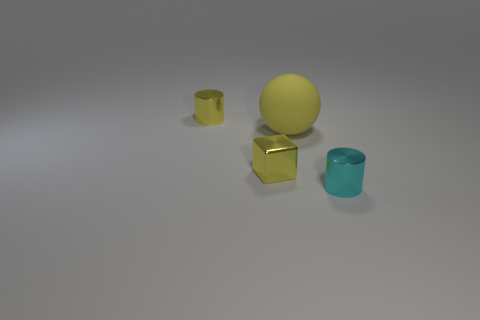Add 1 tiny yellow blocks. How many objects exist? 5 Subtract all blocks. How many objects are left? 3 Add 1 tiny cyan things. How many tiny cyan things are left? 2 Add 2 gray cylinders. How many gray cylinders exist? 2 Subtract 1 yellow balls. How many objects are left? 3 Subtract all tiny blocks. Subtract all yellow rubber things. How many objects are left? 2 